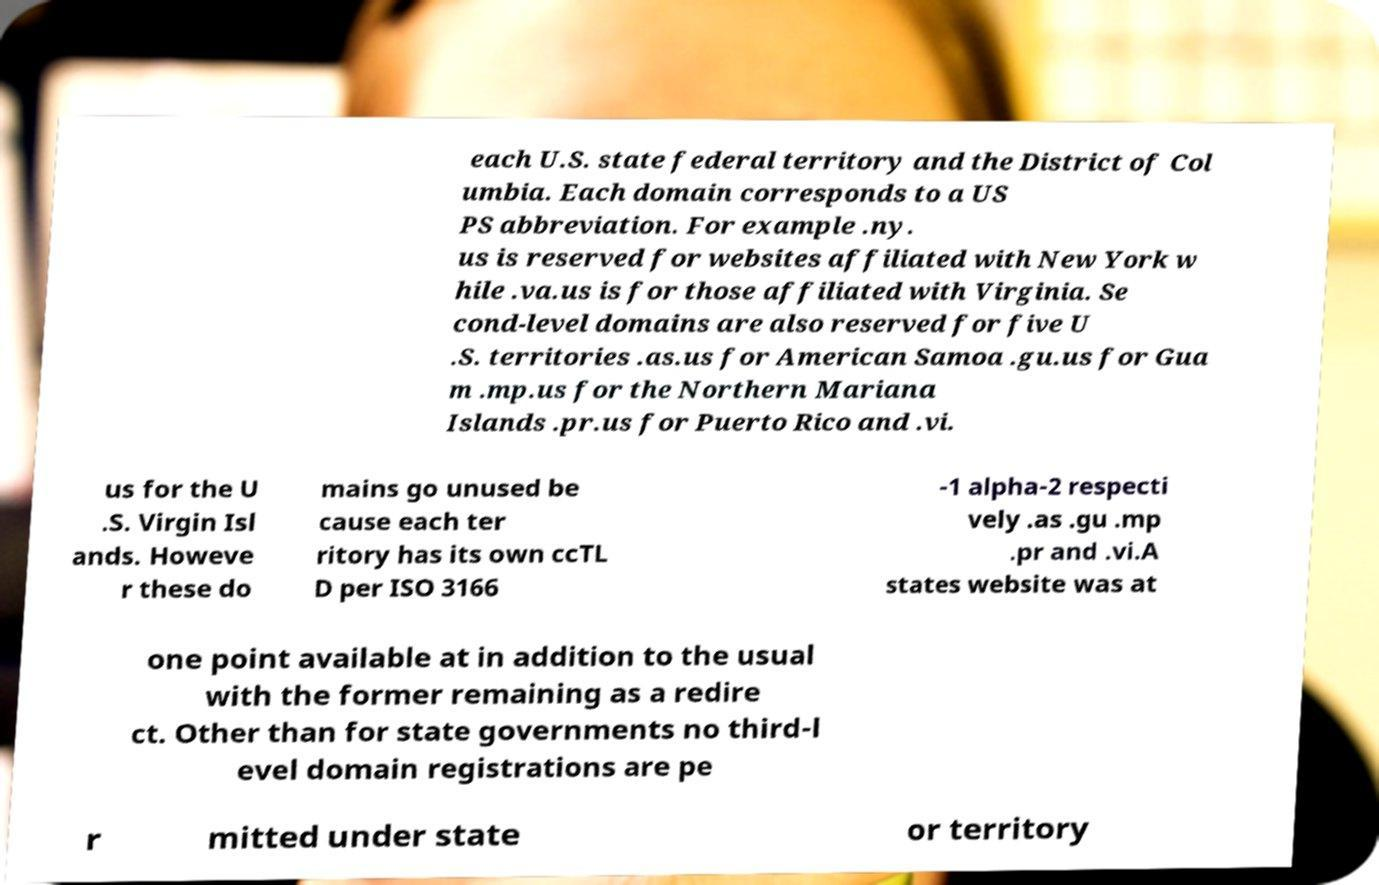I need the written content from this picture converted into text. Can you do that? each U.S. state federal territory and the District of Col umbia. Each domain corresponds to a US PS abbreviation. For example .ny. us is reserved for websites affiliated with New York w hile .va.us is for those affiliated with Virginia. Se cond-level domains are also reserved for five U .S. territories .as.us for American Samoa .gu.us for Gua m .mp.us for the Northern Mariana Islands .pr.us for Puerto Rico and .vi. us for the U .S. Virgin Isl ands. Howeve r these do mains go unused be cause each ter ritory has its own ccTL D per ISO 3166 -1 alpha-2 respecti vely .as .gu .mp .pr and .vi.A states website was at one point available at in addition to the usual with the former remaining as a redire ct. Other than for state governments no third-l evel domain registrations are pe r mitted under state or territory 